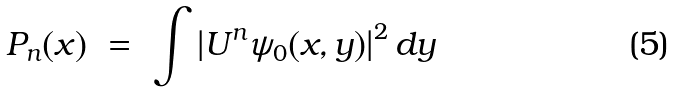Convert formula to latex. <formula><loc_0><loc_0><loc_500><loc_500>P _ { n } ( x ) \ = \ \int \left | U ^ { n } \psi _ { 0 } ( x , y ) \right | ^ { 2 } d y</formula> 